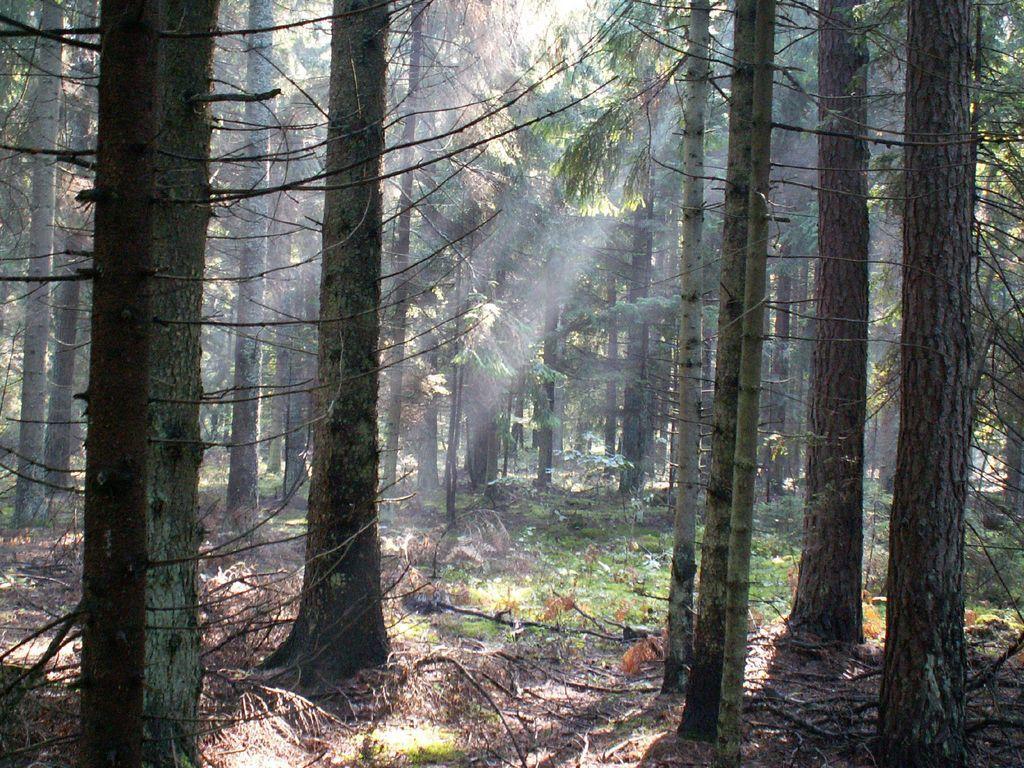In one or two sentences, can you explain what this image depicts? In this picture I can see trees and I can see few sticks and plants on the ground. 